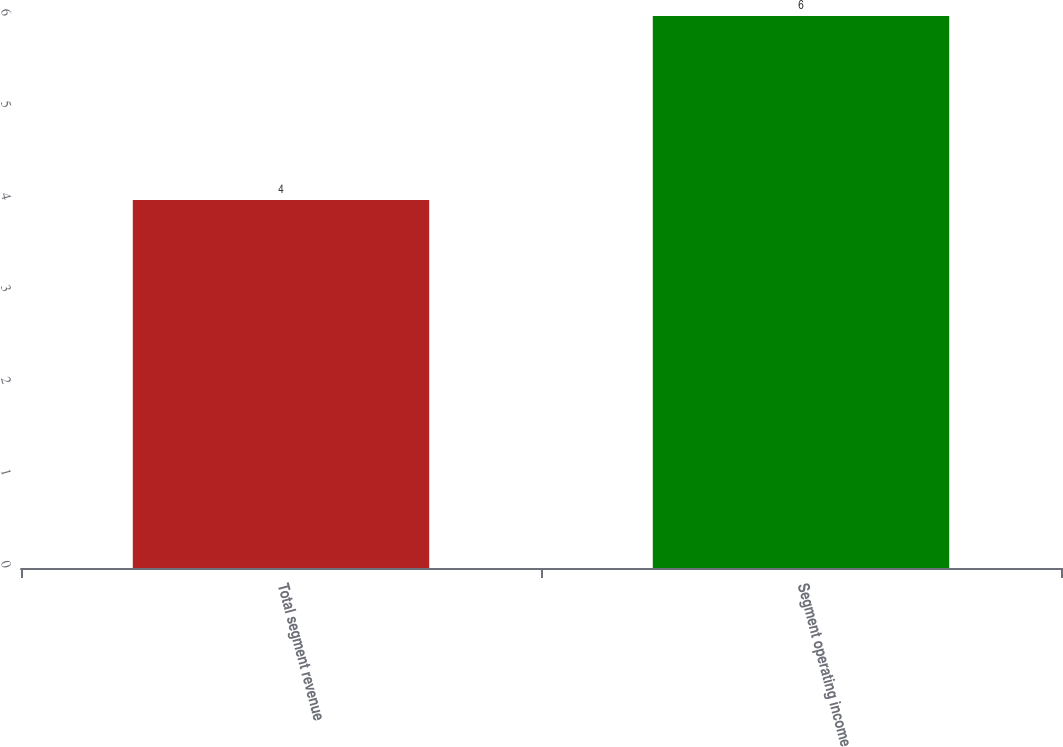Convert chart to OTSL. <chart><loc_0><loc_0><loc_500><loc_500><bar_chart><fcel>Total segment revenue<fcel>Segment operating income<nl><fcel>4<fcel>6<nl></chart> 